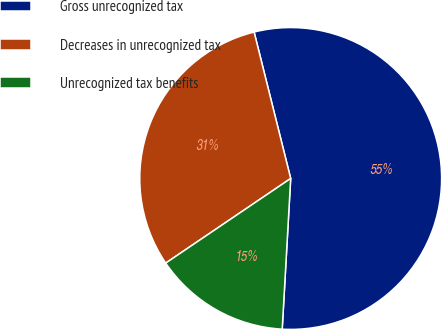Convert chart to OTSL. <chart><loc_0><loc_0><loc_500><loc_500><pie_chart><fcel>Gross unrecognized tax<fcel>Decreases in unrecognized tax<fcel>Unrecognized tax benefits<nl><fcel>54.79%<fcel>30.58%<fcel>14.63%<nl></chart> 